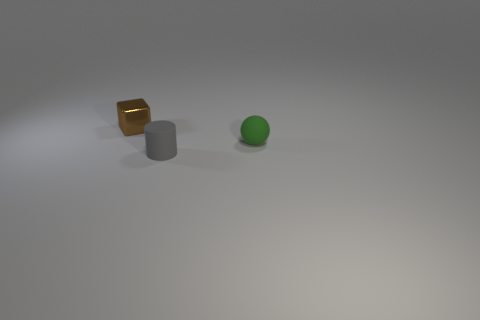How many other objects are the same shape as the green thing?
Your answer should be very brief. 0. There is a tiny matte object behind the tiny object that is in front of the small rubber object behind the gray matte cylinder; what shape is it?
Your answer should be very brief. Sphere. How many things are either tiny cyan things or small things on the right side of the brown metallic block?
Your response must be concise. 2. Do the thing to the right of the gray rubber cylinder and the small thing that is to the left of the tiny gray rubber object have the same shape?
Offer a terse response. No. How many things are either gray matte spheres or objects?
Provide a short and direct response. 3. Is there any other thing that has the same material as the green thing?
Make the answer very short. Yes. Is there a brown metal cube?
Offer a terse response. Yes. Do the ball that is behind the small gray thing and the cube have the same material?
Provide a short and direct response. No. Is there a small cyan shiny object that has the same shape as the gray thing?
Make the answer very short. No. Are there the same number of matte spheres left of the matte sphere and small yellow matte balls?
Your response must be concise. Yes. 